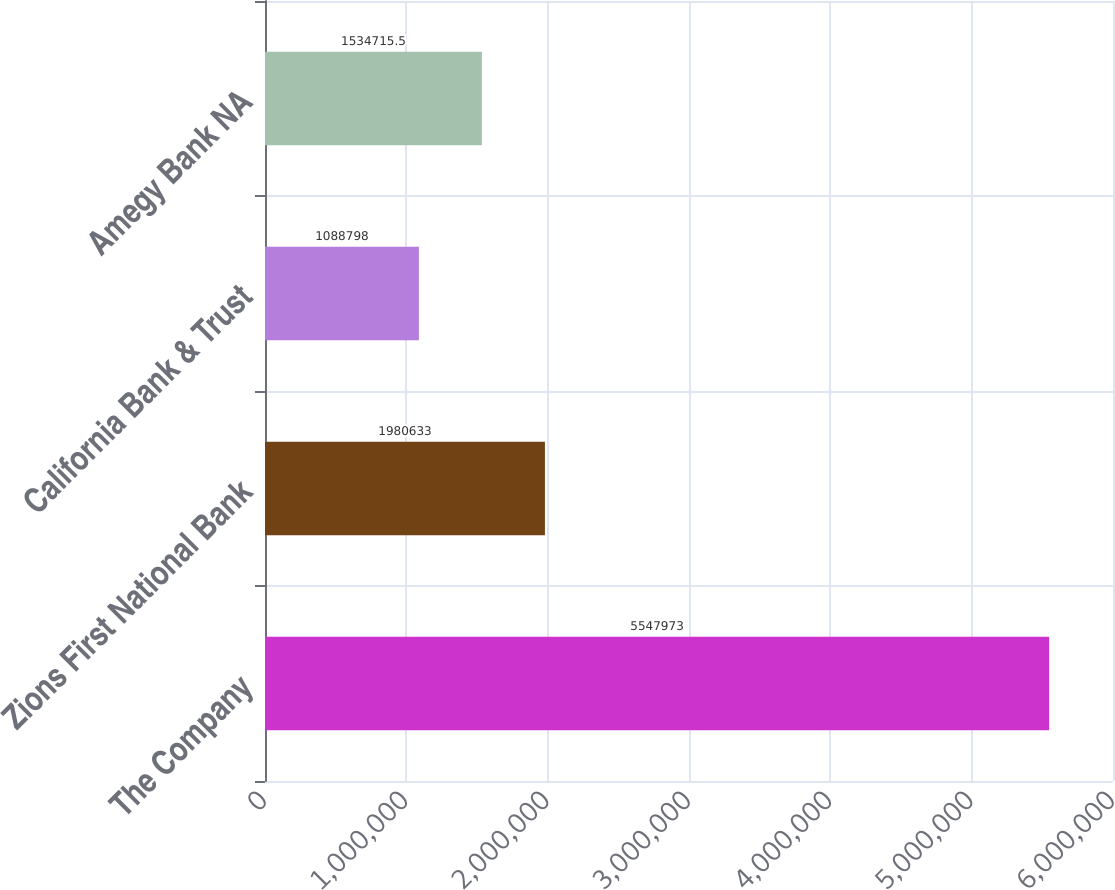<chart> <loc_0><loc_0><loc_500><loc_500><bar_chart><fcel>The Company<fcel>Zions First National Bank<fcel>California Bank & Trust<fcel>Amegy Bank NA<nl><fcel>5.54797e+06<fcel>1.98063e+06<fcel>1.0888e+06<fcel>1.53472e+06<nl></chart> 